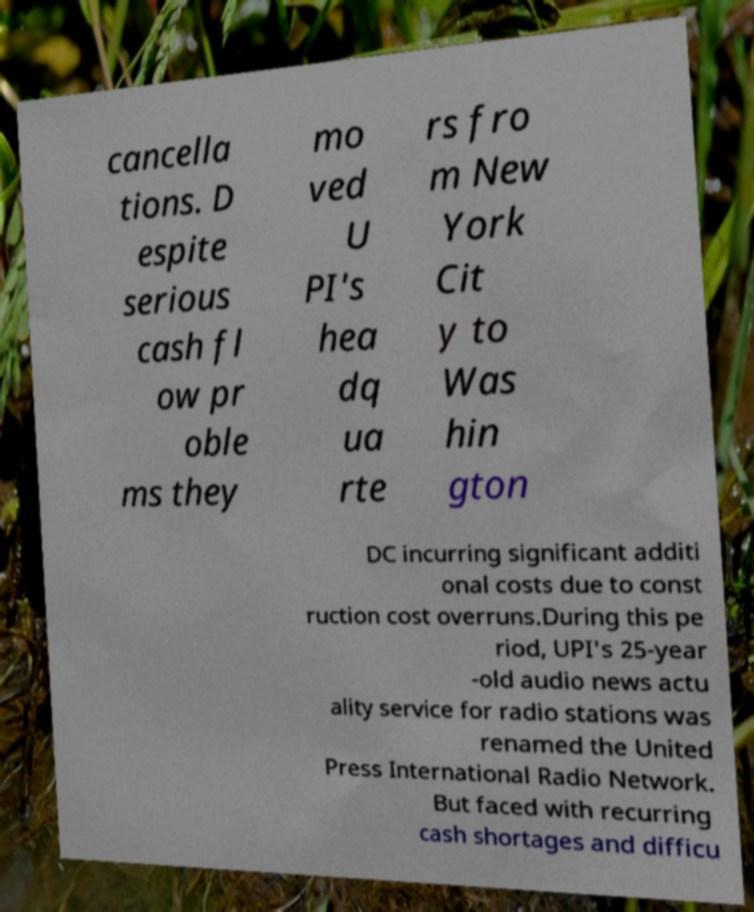Could you assist in decoding the text presented in this image and type it out clearly? cancella tions. D espite serious cash fl ow pr oble ms they mo ved U PI's hea dq ua rte rs fro m New York Cit y to Was hin gton DC incurring significant additi onal costs due to const ruction cost overruns.During this pe riod, UPI's 25-year -old audio news actu ality service for radio stations was renamed the United Press International Radio Network. But faced with recurring cash shortages and difficu 